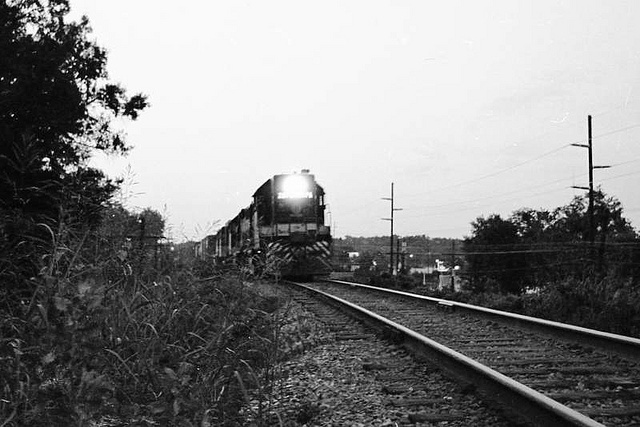Describe the objects in this image and their specific colors. I can see a train in black, gray, white, and darkgray tones in this image. 